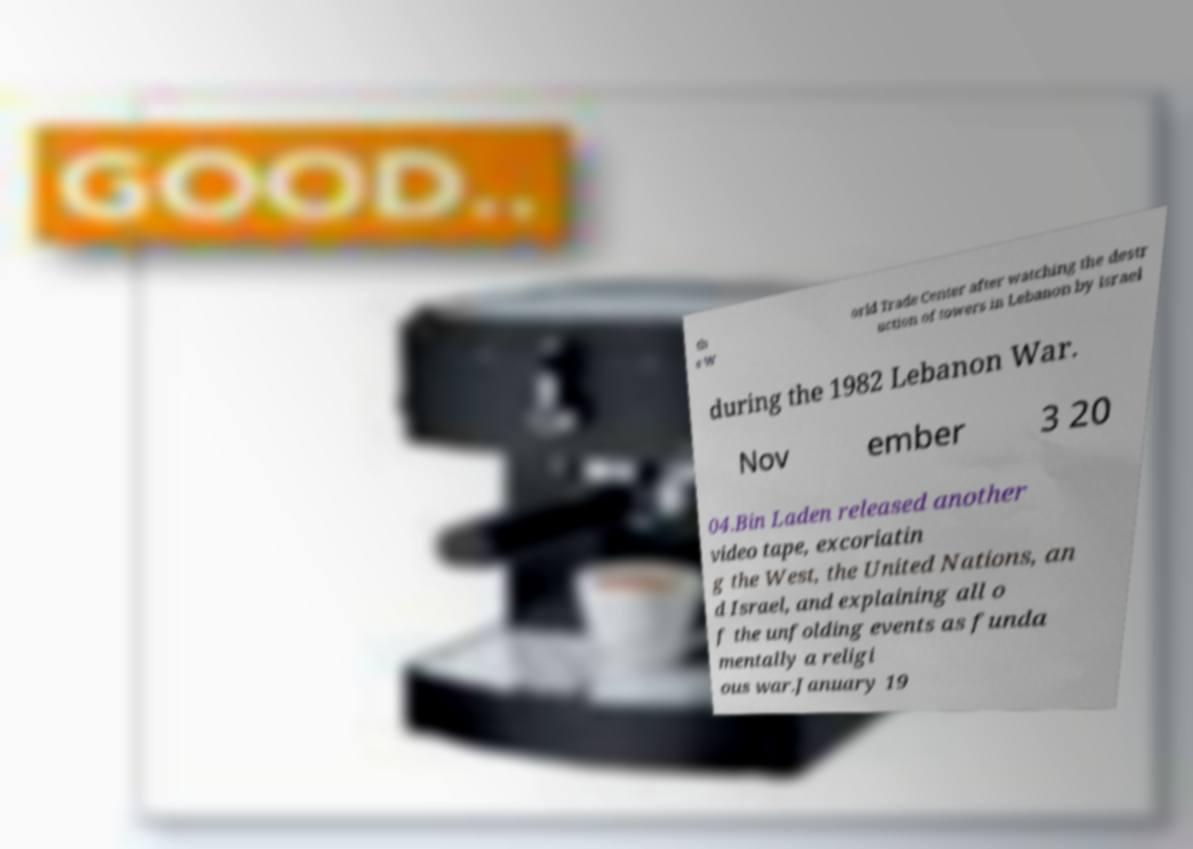Please identify and transcribe the text found in this image. th e W orld Trade Center after watching the destr uction of towers in Lebanon by Israel during the 1982 Lebanon War. Nov ember 3 20 04.Bin Laden released another video tape, excoriatin g the West, the United Nations, an d Israel, and explaining all o f the unfolding events as funda mentally a religi ous war.January 19 